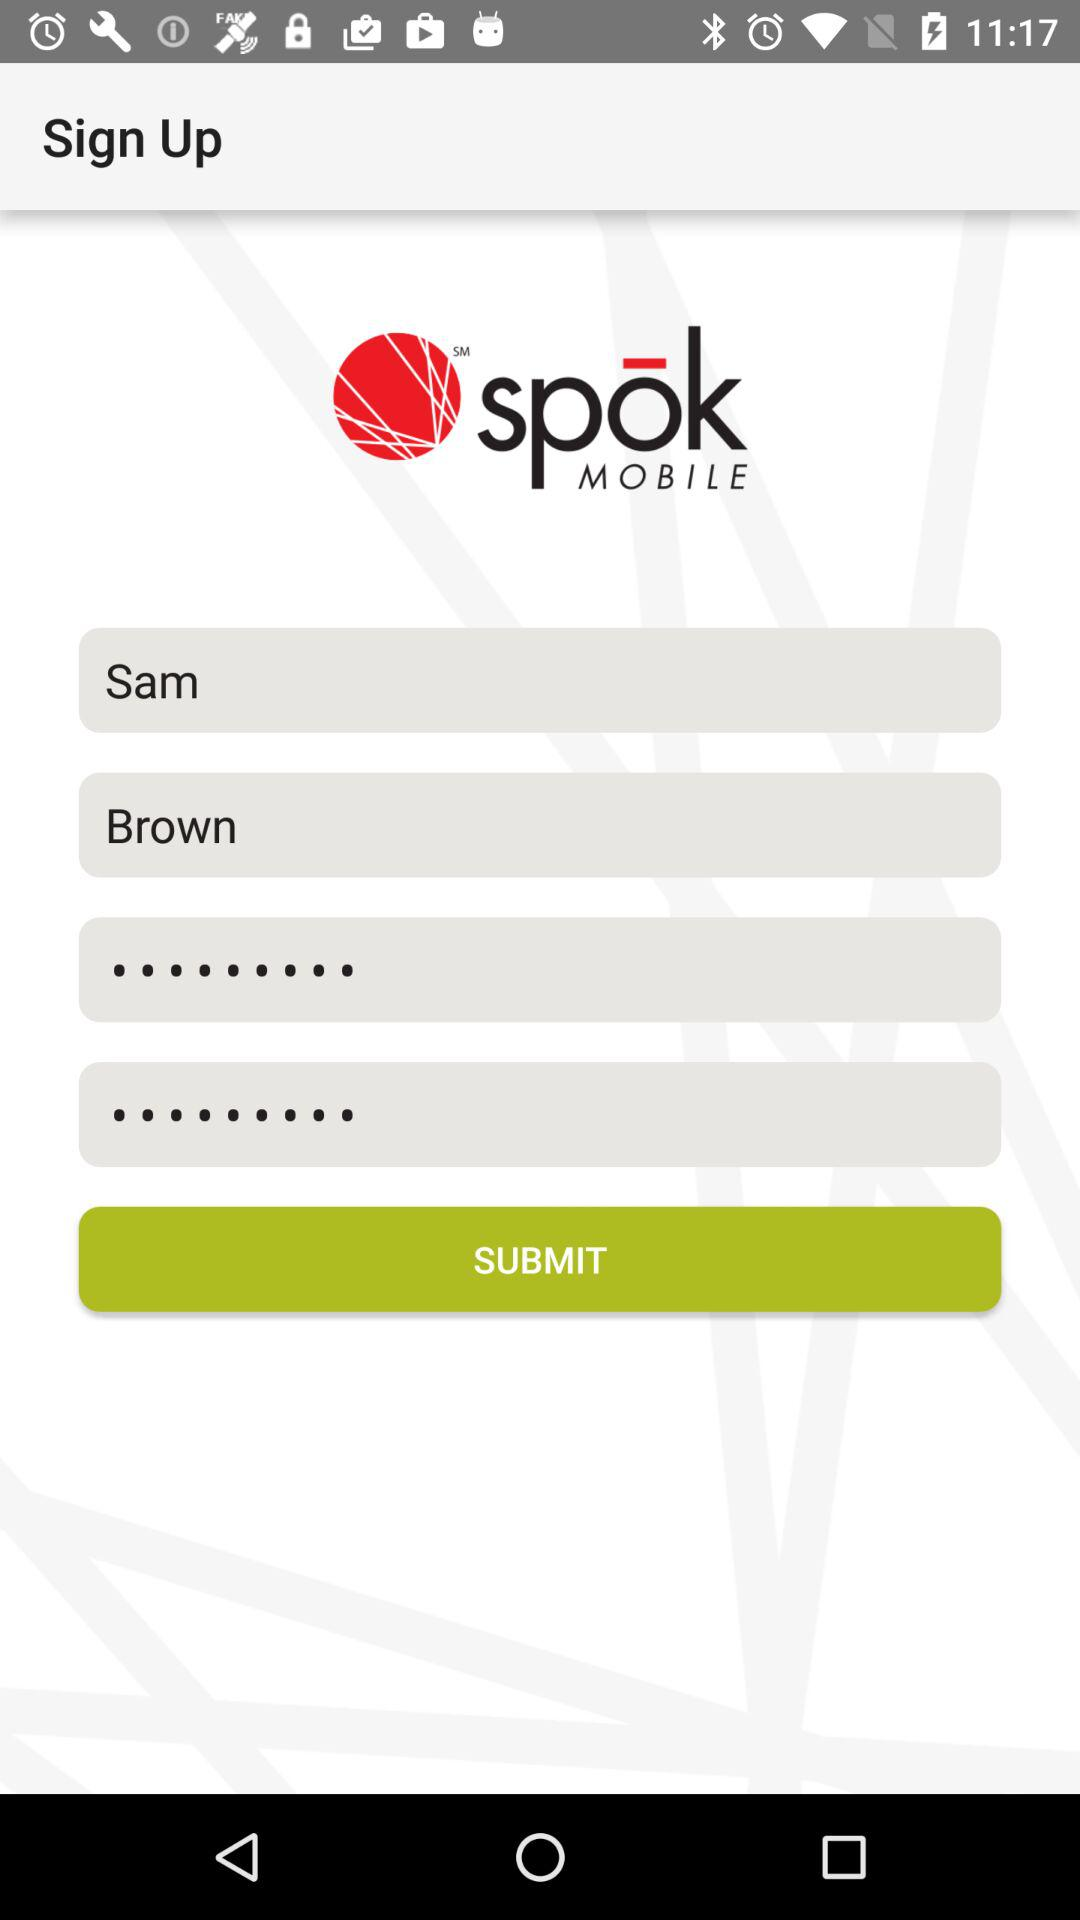What is the last name of the user? The last name of the user is Brown. 